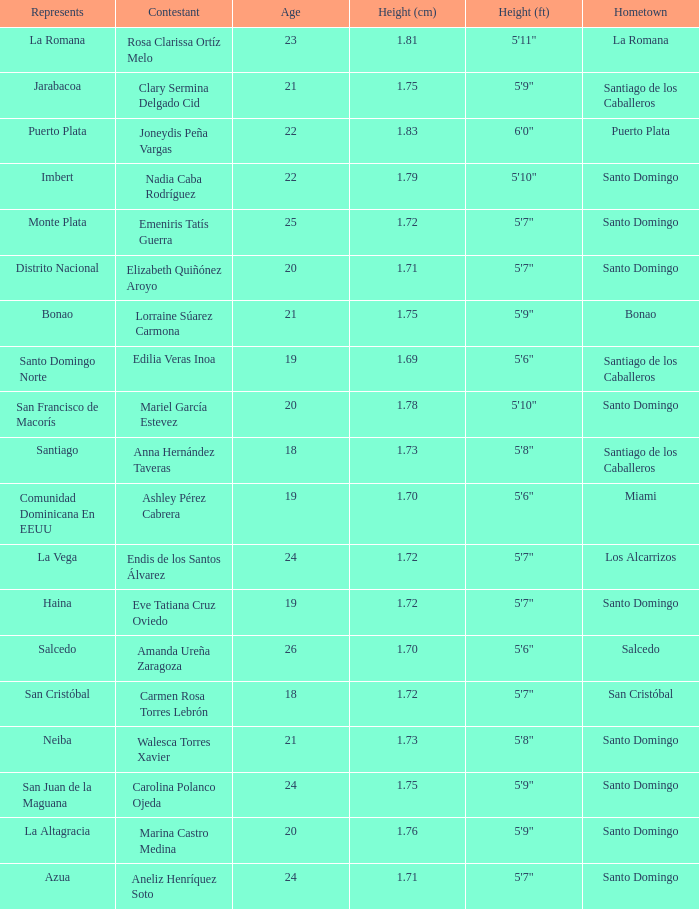Name the total number of represents for clary sermina delgado cid 1.0. 